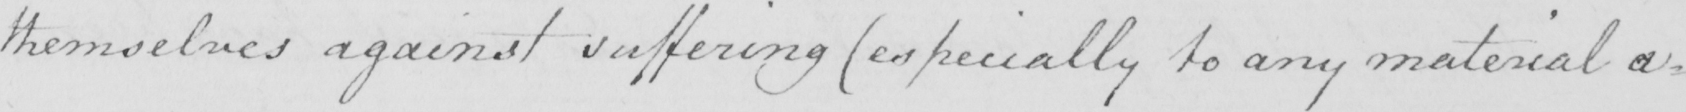Transcribe the text shown in this historical manuscript line. themselves against suffering  ( especially to any material a= 